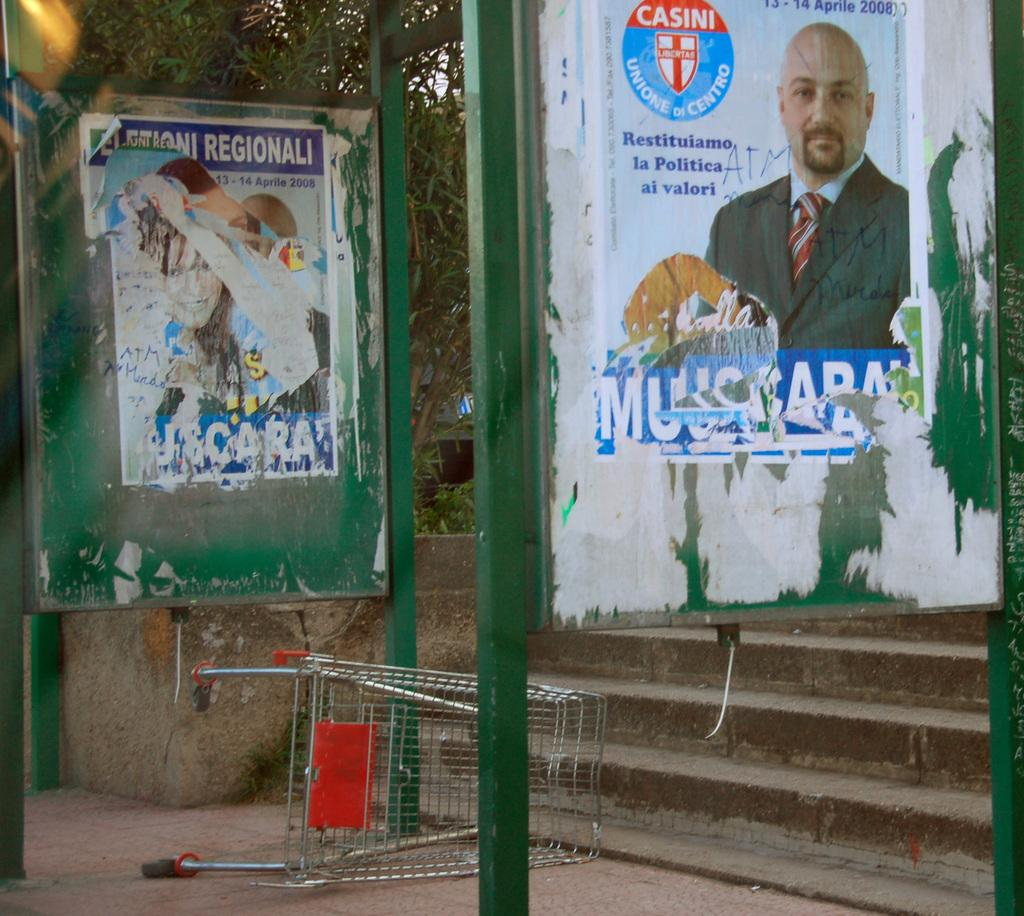<image>
Create a compact narrative representing the image presented. A poster of a man in a suit at a bus stop sponsored by Casini. 